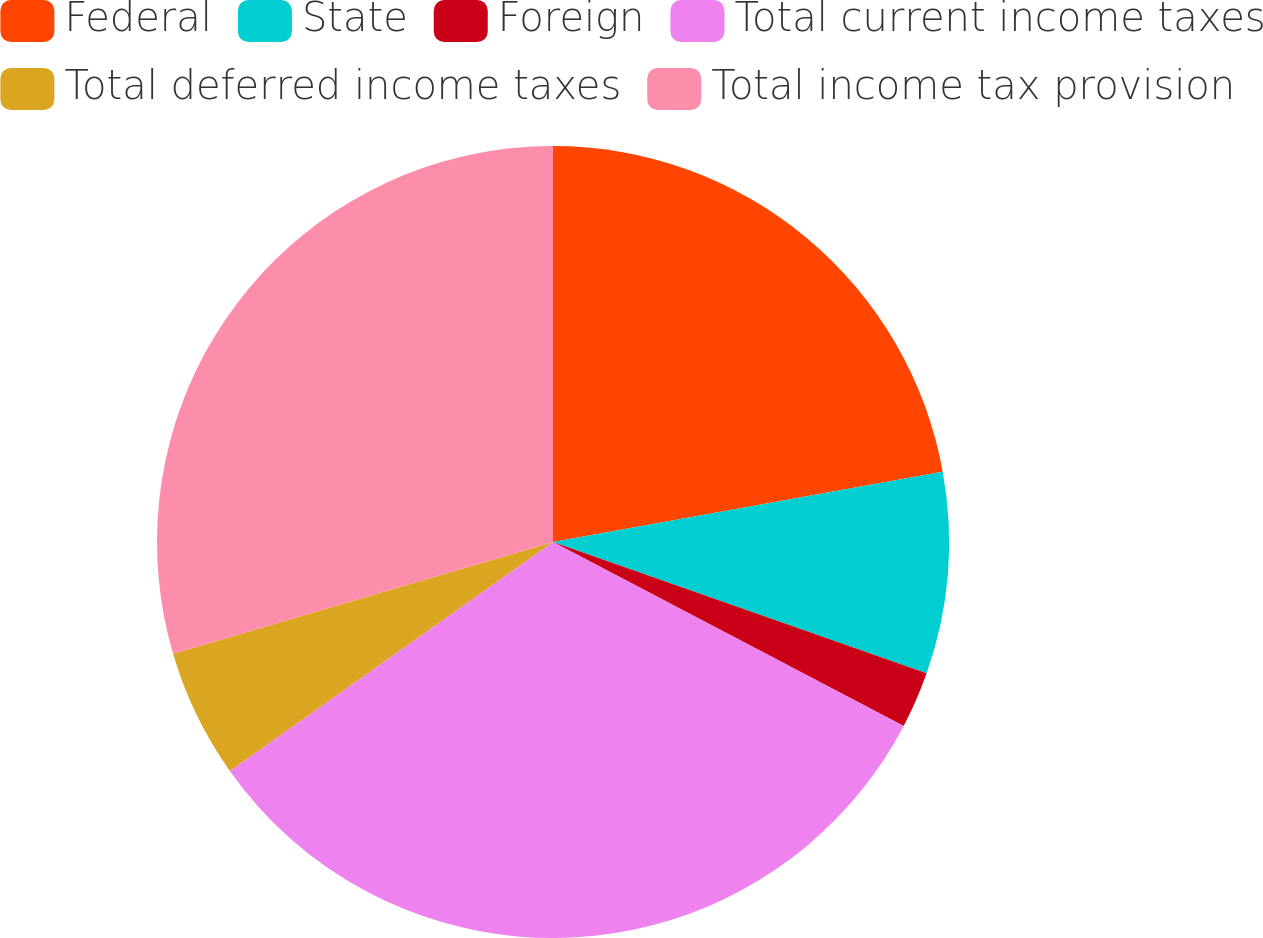<chart> <loc_0><loc_0><loc_500><loc_500><pie_chart><fcel>Federal<fcel>State<fcel>Foreign<fcel>Total current income taxes<fcel>Total deferred income taxes<fcel>Total income tax provision<nl><fcel>22.16%<fcel>8.22%<fcel>2.31%<fcel>32.5%<fcel>5.26%<fcel>29.55%<nl></chart> 